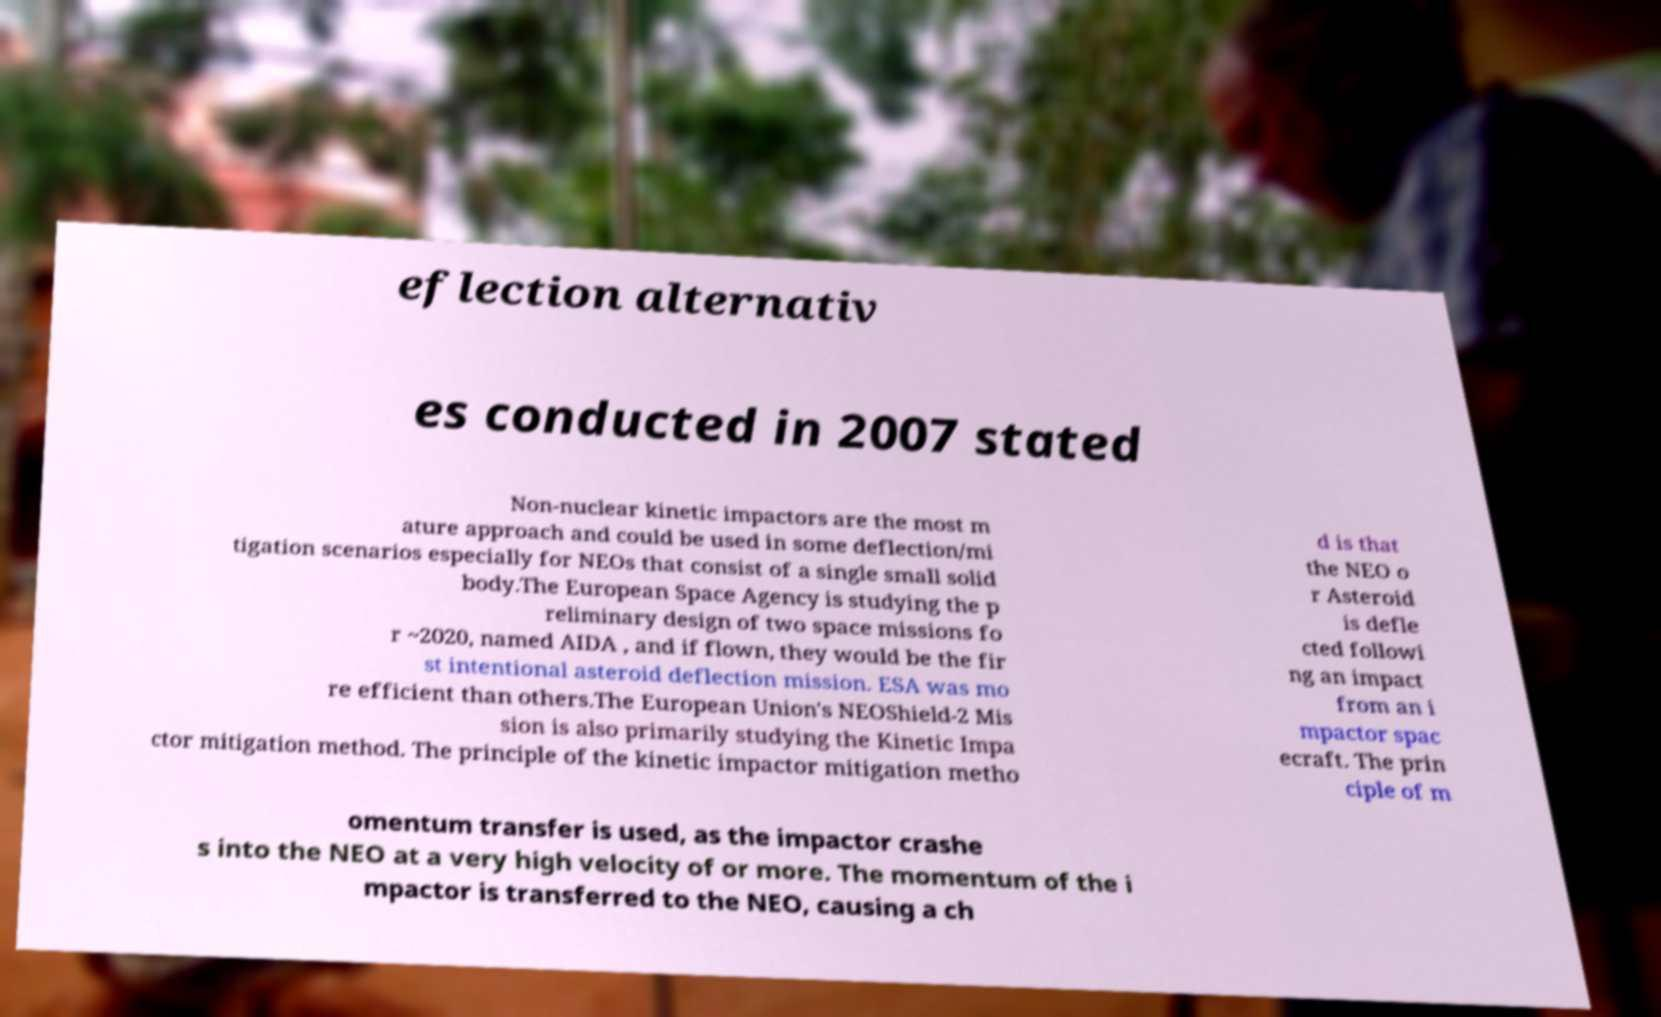For documentation purposes, I need the text within this image transcribed. Could you provide that? eflection alternativ es conducted in 2007 stated Non-nuclear kinetic impactors are the most m ature approach and could be used in some deflection/mi tigation scenarios especially for NEOs that consist of a single small solid body.The European Space Agency is studying the p reliminary design of two space missions fo r ~2020, named AIDA , and if flown, they would be the fir st intentional asteroid deflection mission. ESA was mo re efficient than others.The European Union's NEOShield-2 Mis sion is also primarily studying the Kinetic Impa ctor mitigation method. The principle of the kinetic impactor mitigation metho d is that the NEO o r Asteroid is defle cted followi ng an impact from an i mpactor spac ecraft. The prin ciple of m omentum transfer is used, as the impactor crashe s into the NEO at a very high velocity of or more. The momentum of the i mpactor is transferred to the NEO, causing a ch 